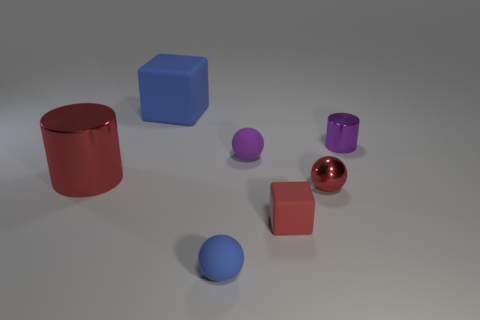How many objects are small red things right of the small red matte object or large purple cylinders?
Keep it short and to the point. 1. There is a tiny thing that is the same color as the big rubber thing; what material is it?
Make the answer very short. Rubber. There is a object that is behind the metal cylinder that is on the right side of the purple ball; is there a small blue thing that is in front of it?
Offer a very short reply. Yes. Are there fewer matte things right of the small blue rubber thing than purple cylinders in front of the small purple shiny cylinder?
Provide a succinct answer. No. There is another tiny sphere that is the same material as the small purple sphere; what color is it?
Your answer should be very brief. Blue. There is a rubber block on the left side of the blue object in front of the red block; what is its color?
Offer a terse response. Blue. Is there a metal cube of the same color as the small cylinder?
Make the answer very short. No. What shape is the red metal object that is the same size as the purple metallic thing?
Provide a succinct answer. Sphere. There is a small red metal object right of the small blue ball; how many red balls are to the left of it?
Your answer should be compact. 0. Is the color of the small block the same as the metallic sphere?
Provide a short and direct response. Yes. 